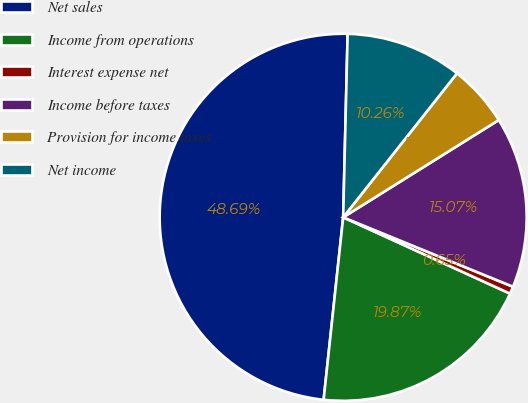Convert chart. <chart><loc_0><loc_0><loc_500><loc_500><pie_chart><fcel>Net sales<fcel>Income from operations<fcel>Interest expense net<fcel>Income before taxes<fcel>Provision for income taxes<fcel>Net income<nl><fcel>48.69%<fcel>19.87%<fcel>0.65%<fcel>15.07%<fcel>5.46%<fcel>10.26%<nl></chart> 